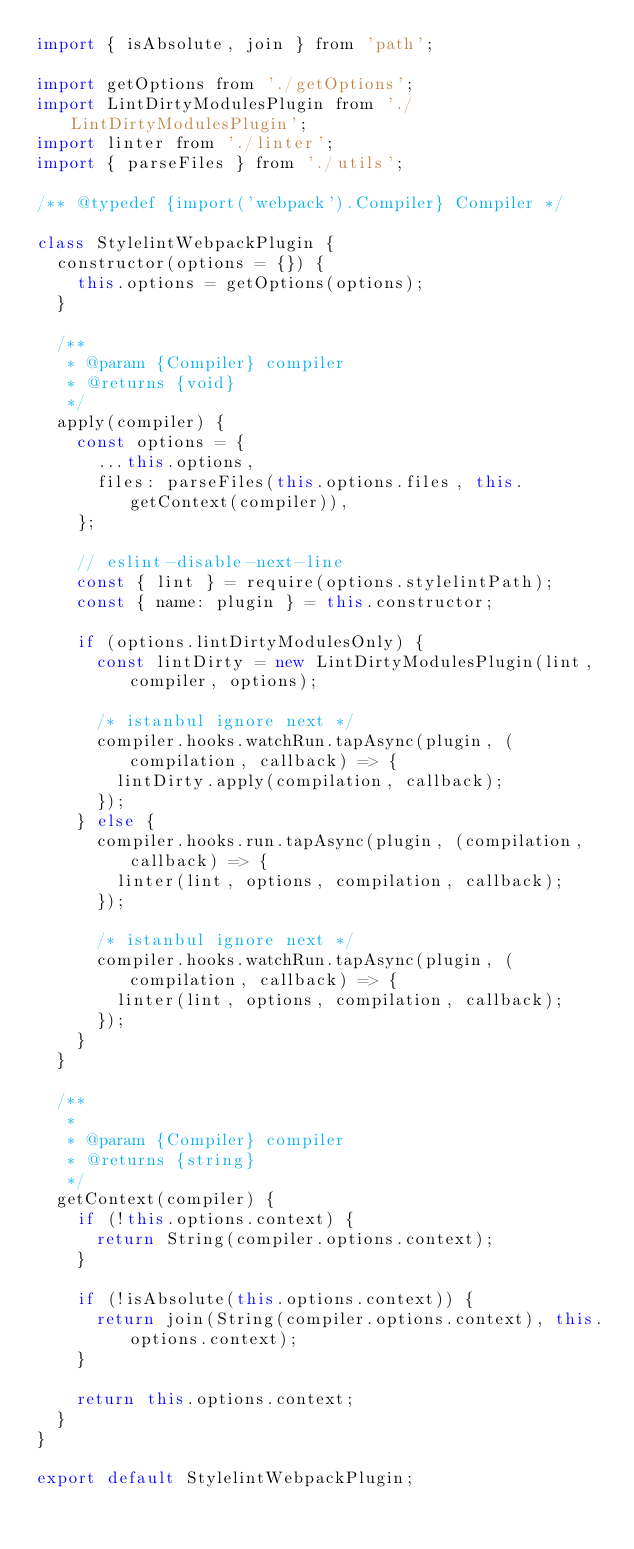<code> <loc_0><loc_0><loc_500><loc_500><_JavaScript_>import { isAbsolute, join } from 'path';

import getOptions from './getOptions';
import LintDirtyModulesPlugin from './LintDirtyModulesPlugin';
import linter from './linter';
import { parseFiles } from './utils';

/** @typedef {import('webpack').Compiler} Compiler */

class StylelintWebpackPlugin {
  constructor(options = {}) {
    this.options = getOptions(options);
  }

  /**
   * @param {Compiler} compiler
   * @returns {void}
   */
  apply(compiler) {
    const options = {
      ...this.options,
      files: parseFiles(this.options.files, this.getContext(compiler)),
    };

    // eslint-disable-next-line
    const { lint } = require(options.stylelintPath);
    const { name: plugin } = this.constructor;

    if (options.lintDirtyModulesOnly) {
      const lintDirty = new LintDirtyModulesPlugin(lint, compiler, options);

      /* istanbul ignore next */
      compiler.hooks.watchRun.tapAsync(plugin, (compilation, callback) => {
        lintDirty.apply(compilation, callback);
      });
    } else {
      compiler.hooks.run.tapAsync(plugin, (compilation, callback) => {
        linter(lint, options, compilation, callback);
      });

      /* istanbul ignore next */
      compiler.hooks.watchRun.tapAsync(plugin, (compilation, callback) => {
        linter(lint, options, compilation, callback);
      });
    }
  }

  /**
   *
   * @param {Compiler} compiler
   * @returns {string}
   */
  getContext(compiler) {
    if (!this.options.context) {
      return String(compiler.options.context);
    }

    if (!isAbsolute(this.options.context)) {
      return join(String(compiler.options.context), this.options.context);
    }

    return this.options.context;
  }
}

export default StylelintWebpackPlugin;
</code> 